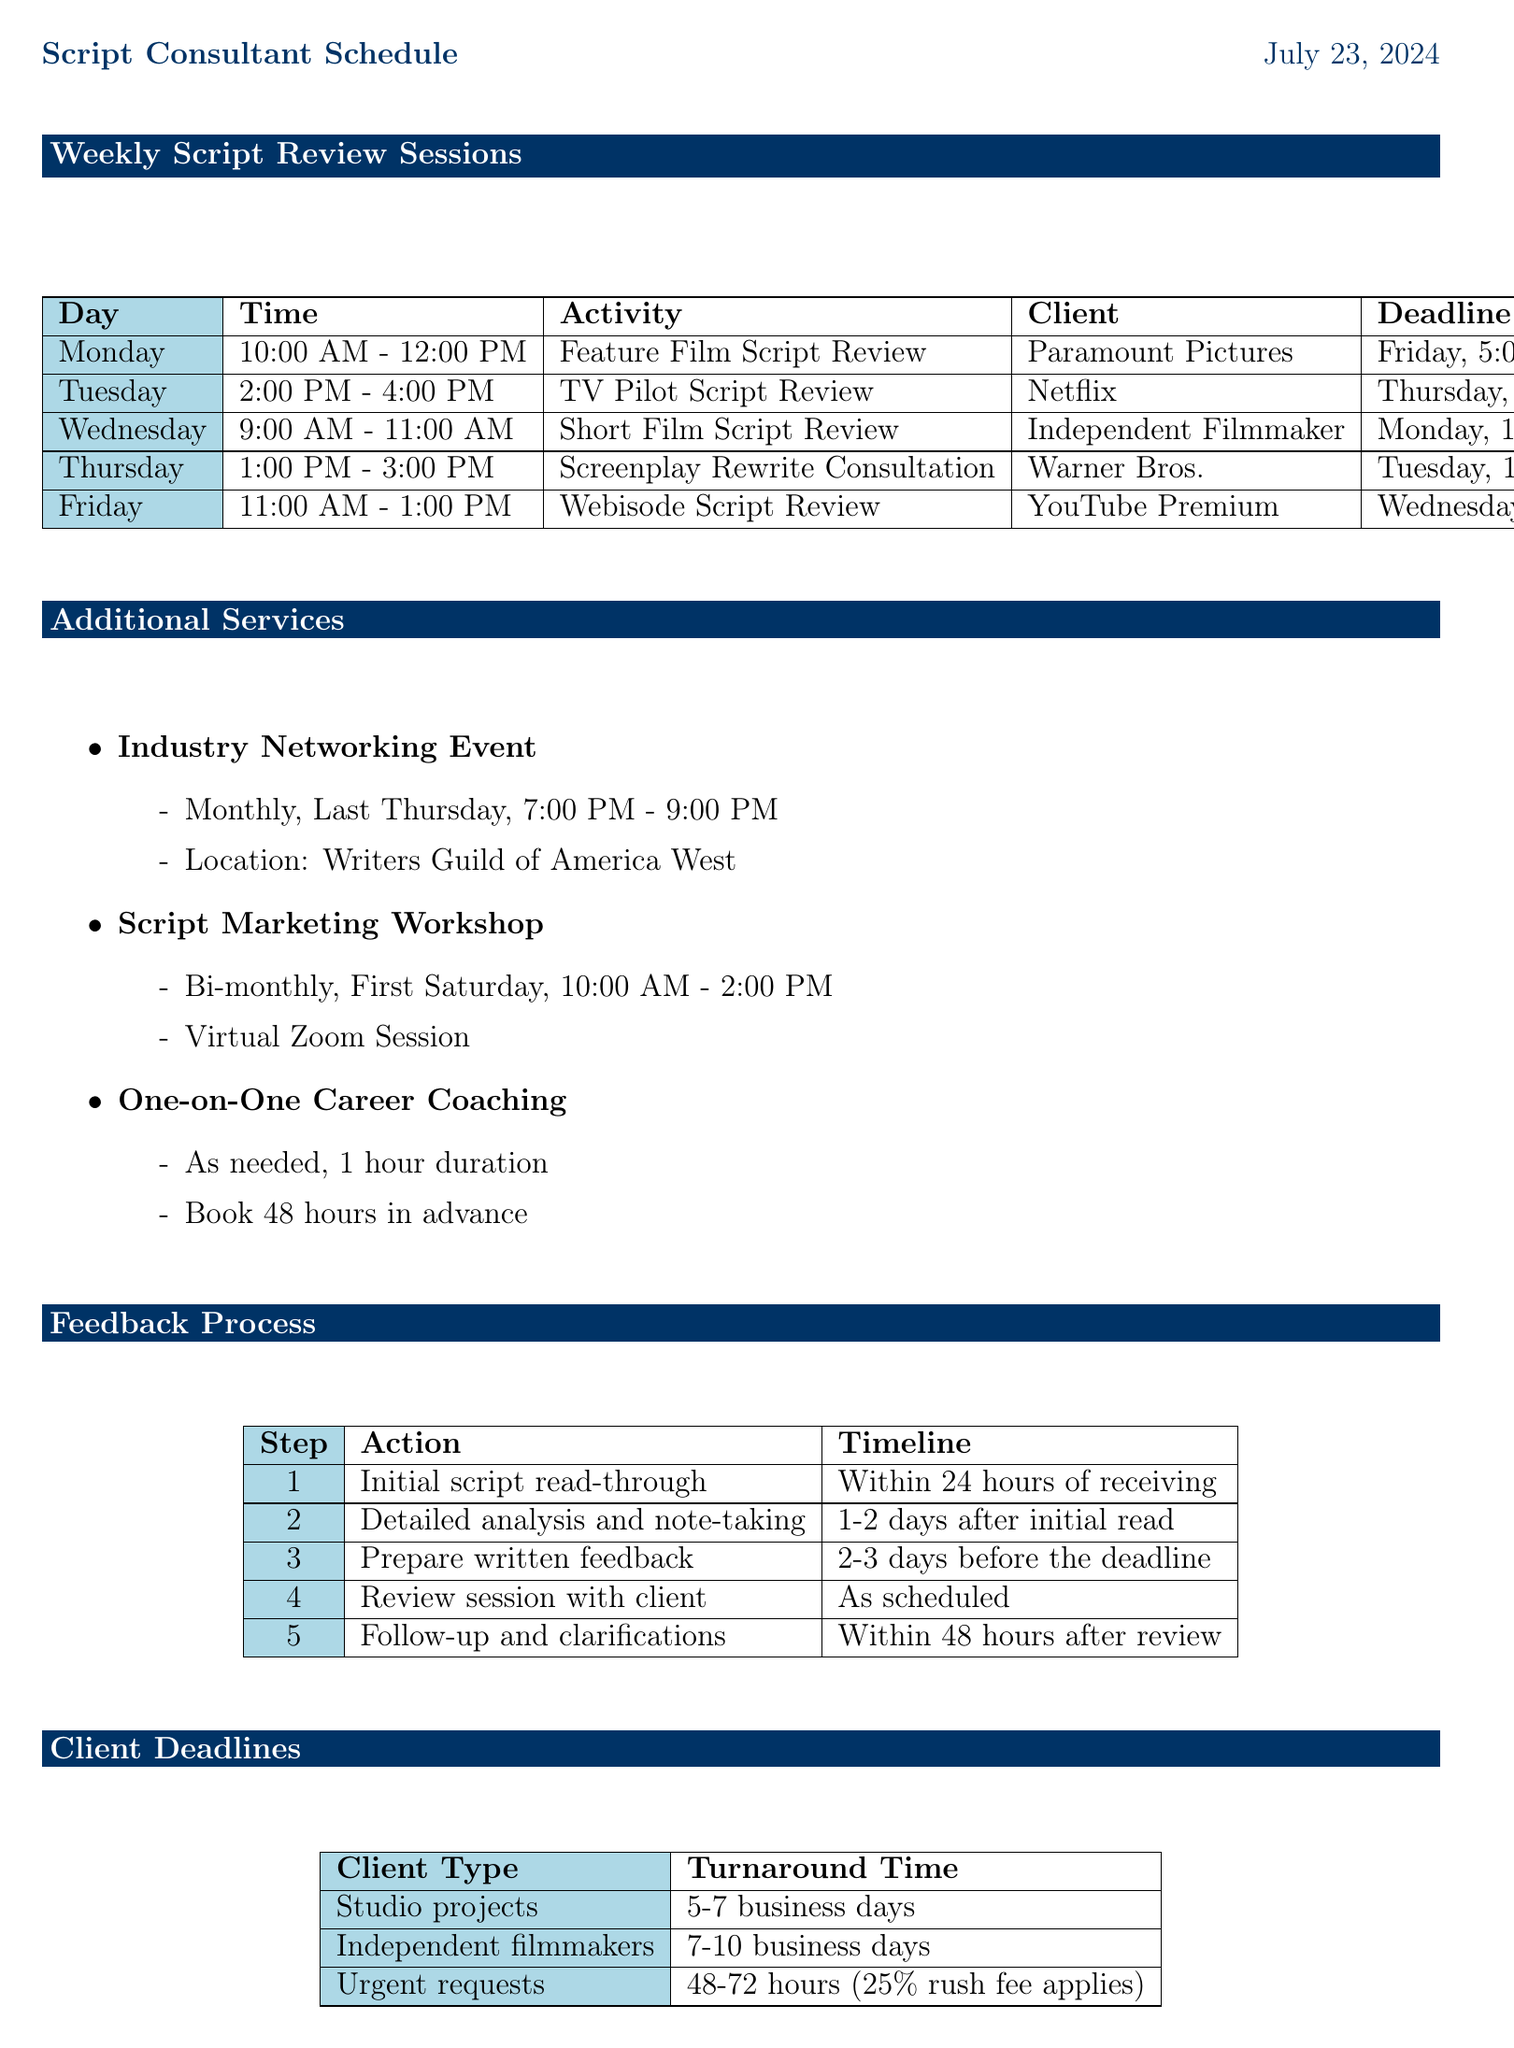What is the client for the Feature Film Script Review? The document lists Paramount Pictures as the client for the Feature Film Script Review on Monday.
Answer: Paramount Pictures What is the time slot for the TV Pilot Script Review? The document indicates that the TV Pilot Script Review is scheduled for Tuesday from 2:00 PM to 4:00 PM.
Answer: 2:00 PM - 4:00 PM When is the deadline for the Short Film Script Review? According to the schedule, the deadline for the Short Film Script Review is Monday at 12:00 PM.
Answer: Monday, 12:00 PM How often is the Industry Networking Event held? The document states that the Industry Networking Event occurs monthly, specifically on the last Thursday of every month.
Answer: Monthly What feedback format is used for the Webisode Script Review? The feedback format stated for the Webisode Script Review includes bullet-point feedback and a Zoom call.
Answer: Bullet-point feedback and Zoom call Which client has a feedback session for a screenplay rewrite? The schedule lists Warner Bros. as the client for the screenplay rewrite consultation on Thursday.
Answer: Warner Bros What is the turnaround time for urgent requests? The document specifies that urgent requests have a turnaround time of 48 to 72 hours, with a 25% rush fee applicable.
Answer: 48-72 hours How long before a scheduled review should written feedback be prepared? The timeline in the feedback process indicates that written feedback should be prepared 2 to 3 days before the deadline.
Answer: 2-3 days What action follows the initial script read-through? The next action after the initial read-through is detailed analysis and note-taking, which occurs 1 to 2 days after the initial read.
Answer: Detailed analysis and note-taking 